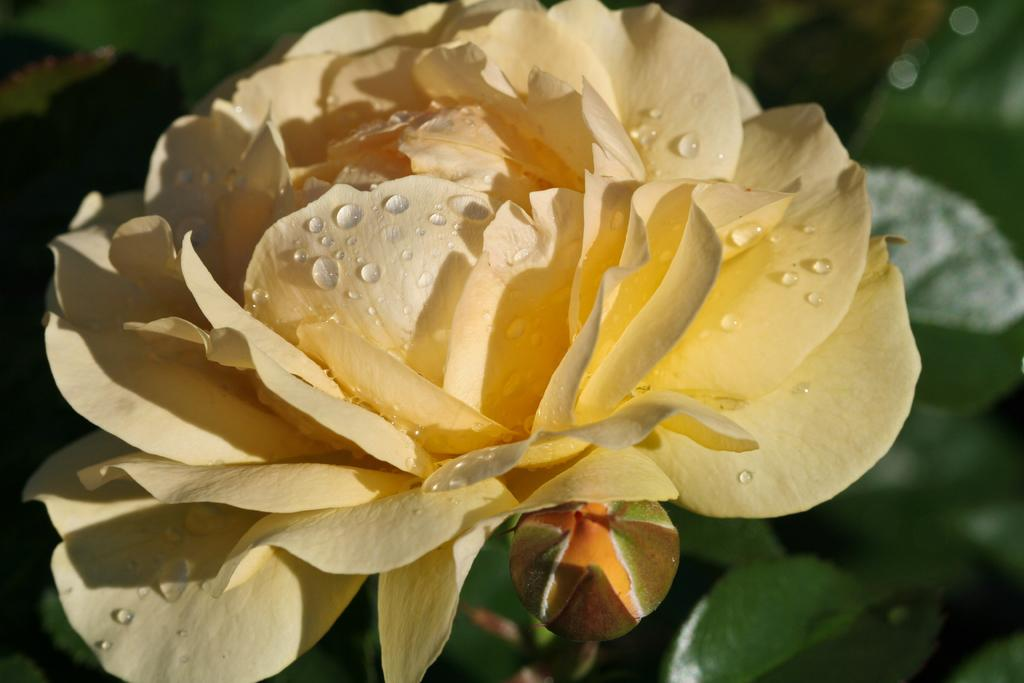What type of flower is in the image? There is a rose flower in the image. Can you describe the condition of the rose flower? The rose flower has water drops on it. What is the stage of the flower's growth that is visible in the image? There is a bud under the rose flower. What color can be seen in the background of the image? Green color leaves are visible in the background of the image. What type of structure can be seen in the background of the image? There is no structure visible in the background of the image; only green color leaves are present. Can you tell me how many snakes are coiled around the rose flower in the image? There are no snakes present in the image; it features a rose flower with water drops and a bud. 